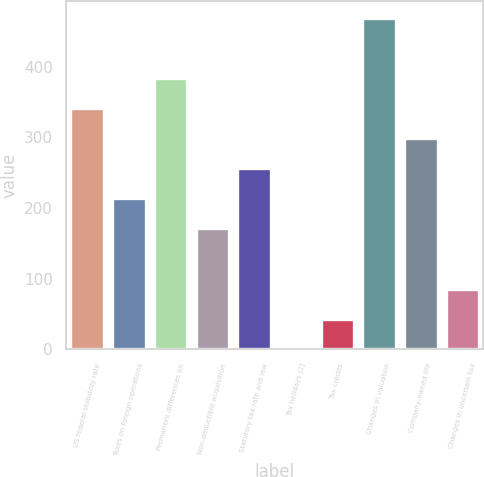<chart> <loc_0><loc_0><loc_500><loc_500><bar_chart><fcel>US federal statutory rate<fcel>Taxes on foreign operations<fcel>Permanent differences on<fcel>Non-deductible acquisition<fcel>Statutory tax rate and law<fcel>Tax holidays (2)<fcel>Tax credits<fcel>Changes in valuation<fcel>Company-owned life<fcel>Changes in uncertain tax<nl><fcel>341.6<fcel>213.8<fcel>384.2<fcel>171.2<fcel>256.4<fcel>0.8<fcel>43.4<fcel>469.4<fcel>299<fcel>86<nl></chart> 